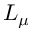Convert formula to latex. <formula><loc_0><loc_0><loc_500><loc_500>L _ { \mu }</formula> 